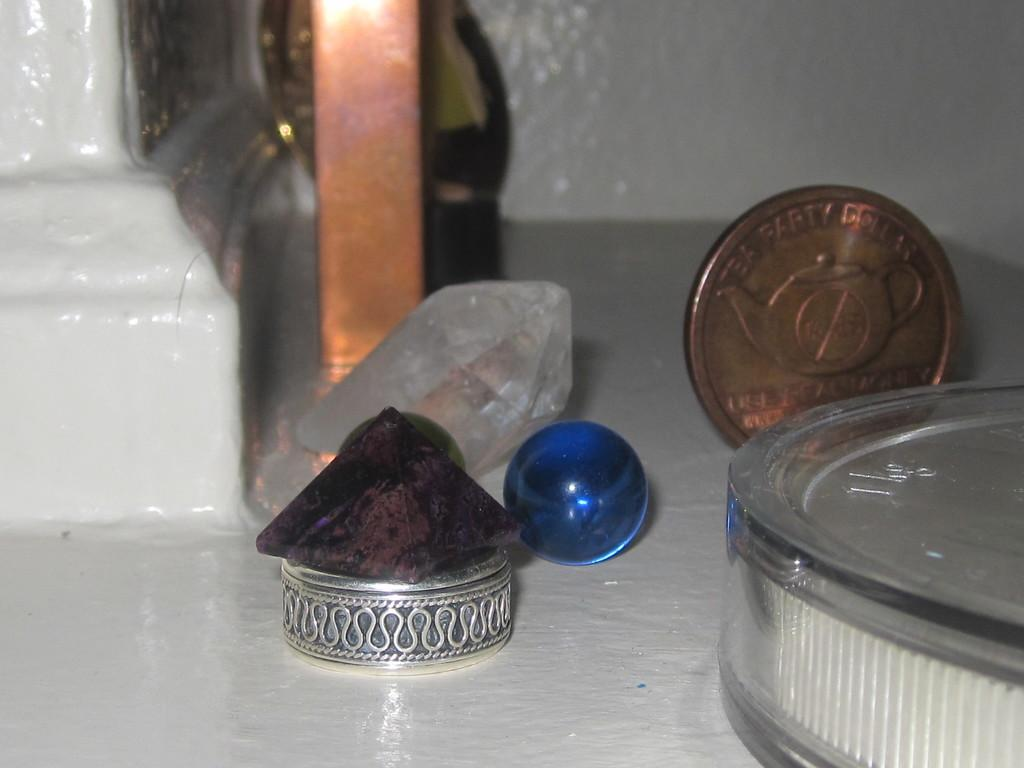<image>
Describe the image concisely. A coin is inscribed with the message TEA PARTY DOLLAR. 